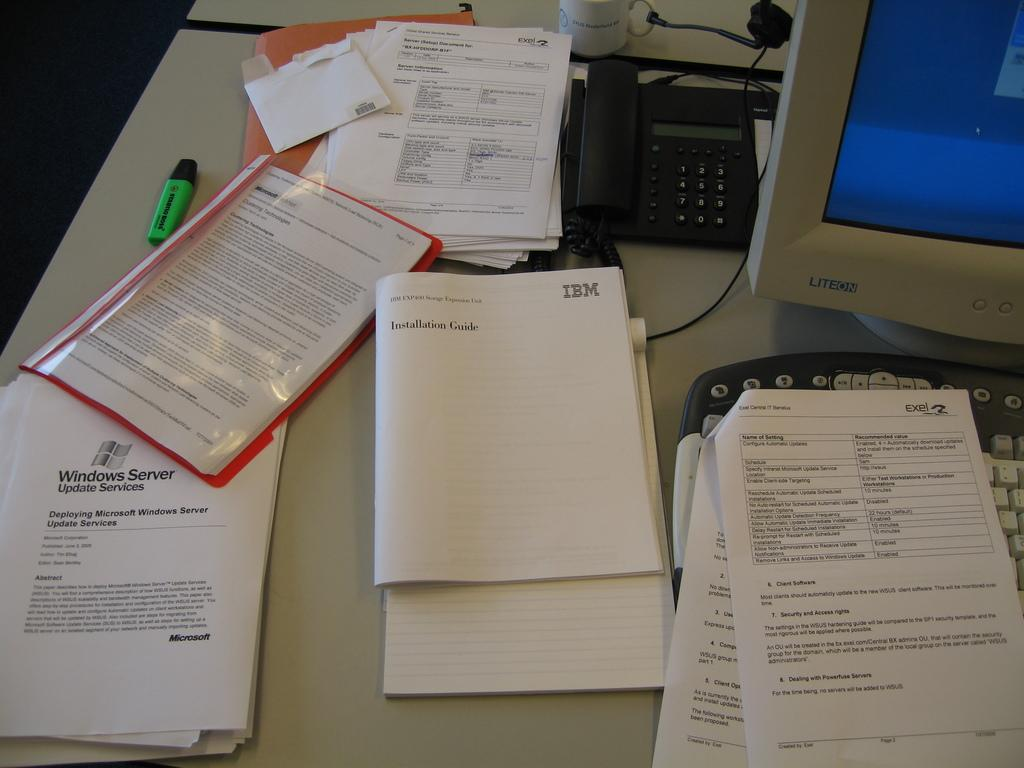<image>
Present a compact description of the photo's key features. Numerous computer documents sit on a desk next to a Liteon computer monitor 